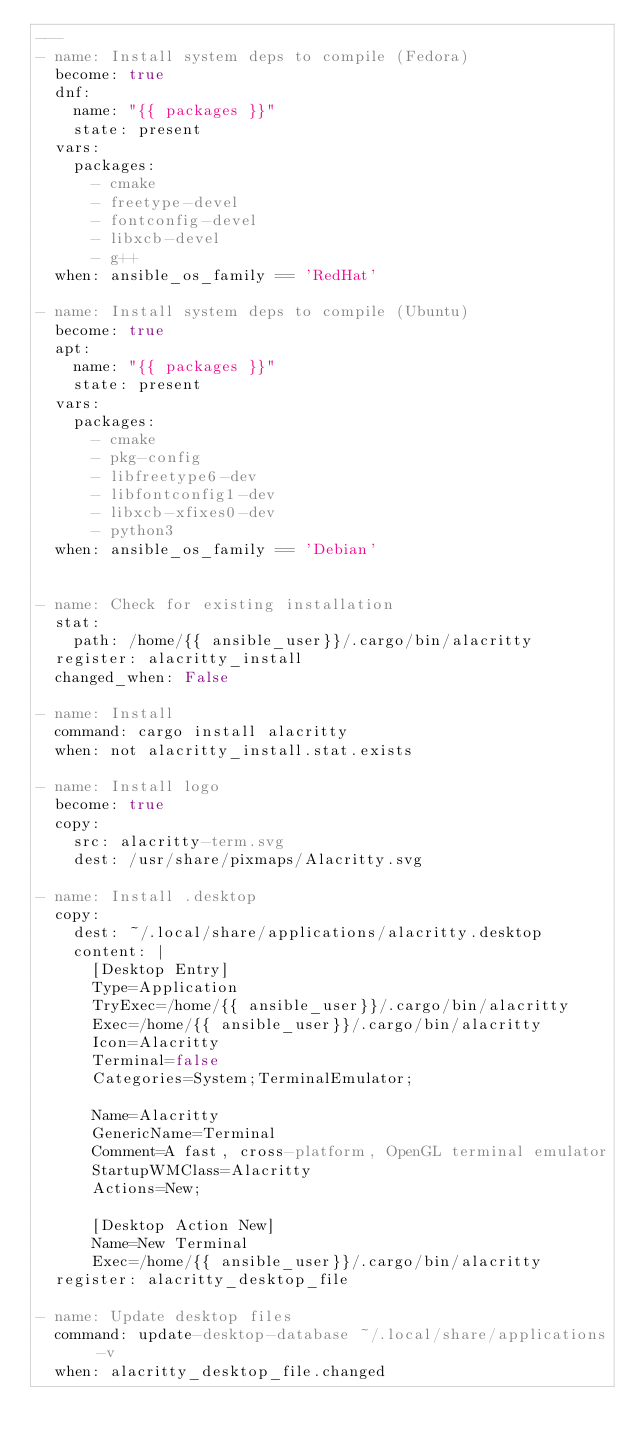<code> <loc_0><loc_0><loc_500><loc_500><_YAML_>---
- name: Install system deps to compile (Fedora)
  become: true
  dnf:
    name: "{{ packages }}"
    state: present
  vars:
    packages:
      - cmake
      - freetype-devel
      - fontconfig-devel
      - libxcb-devel
      - g++
  when: ansible_os_family == 'RedHat'

- name: Install system deps to compile (Ubuntu)
  become: true
  apt:
    name: "{{ packages }}"
    state: present
  vars:
    packages:
      - cmake
      - pkg-config
      - libfreetype6-dev
      - libfontconfig1-dev
      - libxcb-xfixes0-dev
      - python3
  when: ansible_os_family == 'Debian'


- name: Check for existing installation
  stat:
    path: /home/{{ ansible_user}}/.cargo/bin/alacritty
  register: alacritty_install
  changed_when: False

- name: Install
  command: cargo install alacritty
  when: not alacritty_install.stat.exists

- name: Install logo
  become: true
  copy:
    src: alacritty-term.svg
    dest: /usr/share/pixmaps/Alacritty.svg

- name: Install .desktop
  copy:
    dest: ~/.local/share/applications/alacritty.desktop
    content: |
      [Desktop Entry]
      Type=Application
      TryExec=/home/{{ ansible_user}}/.cargo/bin/alacritty
      Exec=/home/{{ ansible_user}}/.cargo/bin/alacritty
      Icon=Alacritty
      Terminal=false
      Categories=System;TerminalEmulator;

      Name=Alacritty
      GenericName=Terminal
      Comment=A fast, cross-platform, OpenGL terminal emulator
      StartupWMClass=Alacritty
      Actions=New;

      [Desktop Action New]
      Name=New Terminal
      Exec=/home/{{ ansible_user}}/.cargo/bin/alacritty
  register: alacritty_desktop_file

- name: Update desktop files
  command: update-desktop-database ~/.local/share/applications -v
  when: alacritty_desktop_file.changed
</code> 